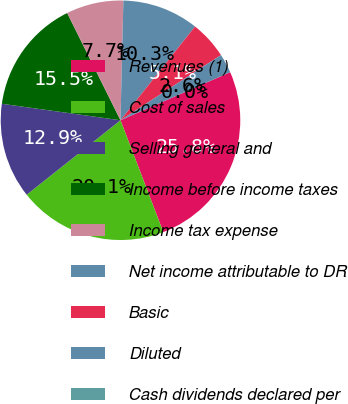<chart> <loc_0><loc_0><loc_500><loc_500><pie_chart><fcel>Revenues (1)<fcel>Cost of sales<fcel>Selling general and<fcel>Income before income taxes<fcel>Income tax expense<fcel>Net income attributable to DR<fcel>Basic<fcel>Diluted<fcel>Cash dividends declared per<nl><fcel>25.76%<fcel>20.14%<fcel>12.88%<fcel>15.46%<fcel>7.73%<fcel>10.31%<fcel>5.15%<fcel>2.58%<fcel>0.0%<nl></chart> 